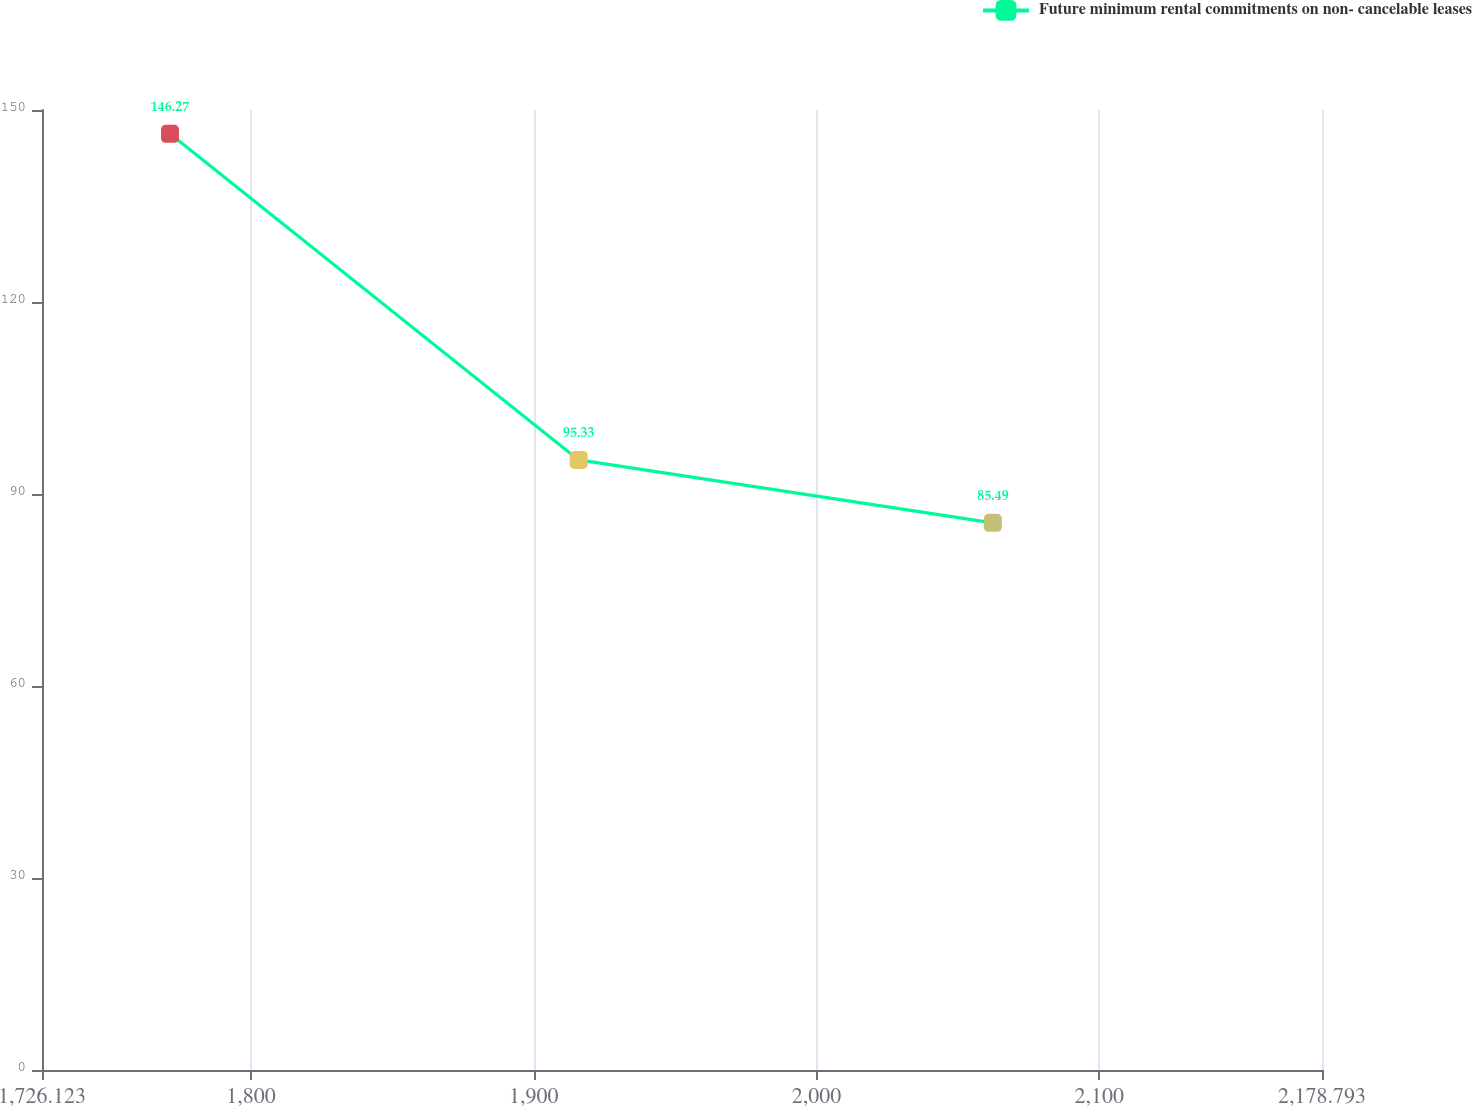Convert chart. <chart><loc_0><loc_0><loc_500><loc_500><line_chart><ecel><fcel>Future minimum rental commitments on non- cancelable leases<nl><fcel>1771.39<fcel>146.27<nl><fcel>1915.91<fcel>95.33<nl><fcel>2062.4<fcel>85.49<nl><fcel>2178.84<fcel>47.9<nl><fcel>2224.06<fcel>64.12<nl></chart> 